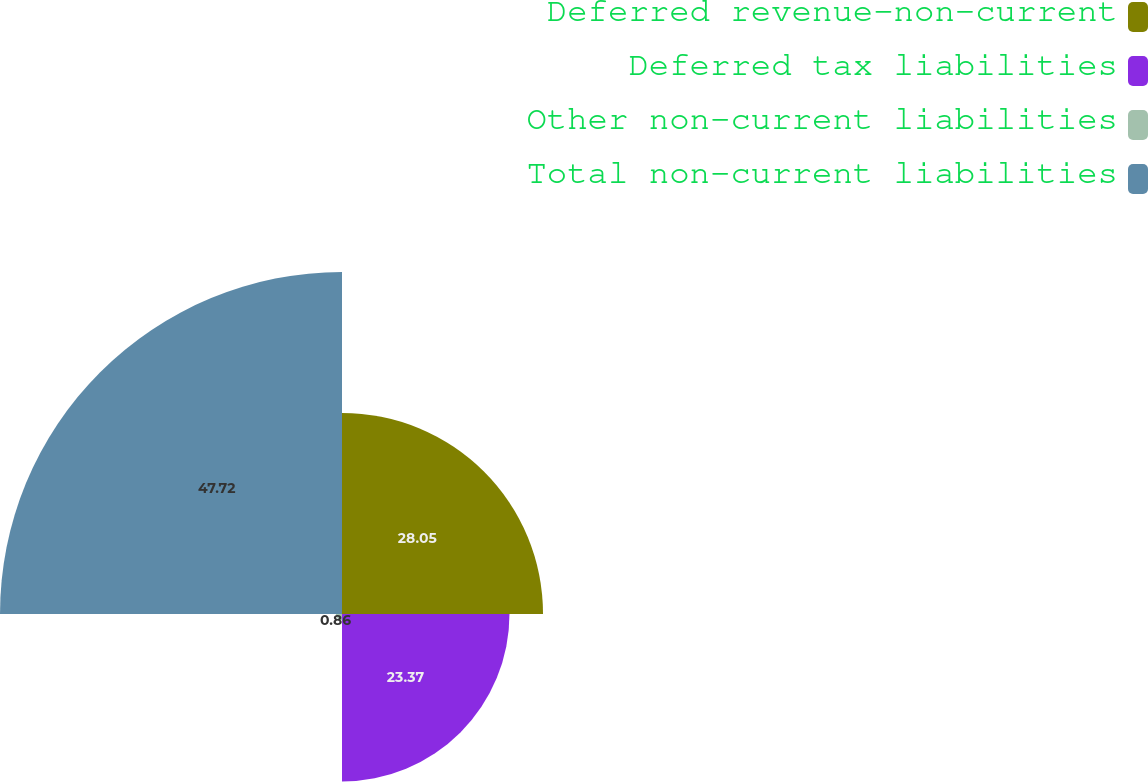<chart> <loc_0><loc_0><loc_500><loc_500><pie_chart><fcel>Deferred revenue-non-current<fcel>Deferred tax liabilities<fcel>Other non-current liabilities<fcel>Total non-current liabilities<nl><fcel>28.05%<fcel>23.37%<fcel>0.86%<fcel>47.72%<nl></chart> 